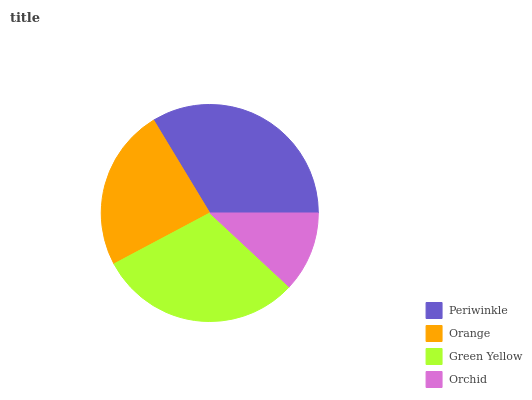Is Orchid the minimum?
Answer yes or no. Yes. Is Periwinkle the maximum?
Answer yes or no. Yes. Is Orange the minimum?
Answer yes or no. No. Is Orange the maximum?
Answer yes or no. No. Is Periwinkle greater than Orange?
Answer yes or no. Yes. Is Orange less than Periwinkle?
Answer yes or no. Yes. Is Orange greater than Periwinkle?
Answer yes or no. No. Is Periwinkle less than Orange?
Answer yes or no. No. Is Green Yellow the high median?
Answer yes or no. Yes. Is Orange the low median?
Answer yes or no. Yes. Is Periwinkle the high median?
Answer yes or no. No. Is Green Yellow the low median?
Answer yes or no. No. 